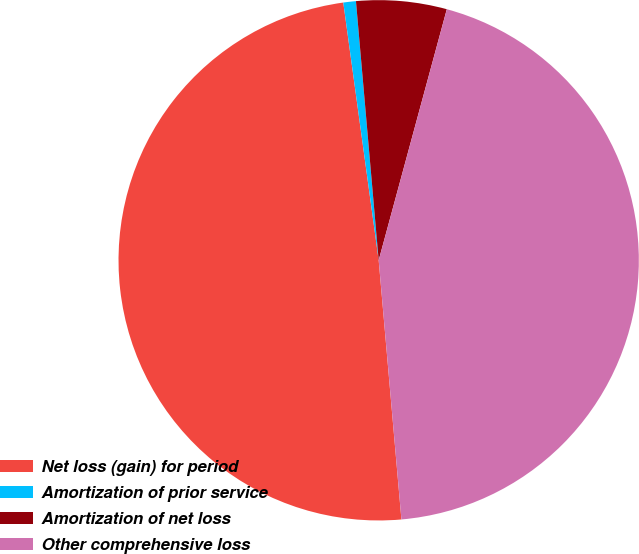Convert chart to OTSL. <chart><loc_0><loc_0><loc_500><loc_500><pie_chart><fcel>Net loss (gain) for period<fcel>Amortization of prior service<fcel>Amortization of net loss<fcel>Other comprehensive loss<nl><fcel>49.22%<fcel>0.78%<fcel>5.61%<fcel>44.39%<nl></chart> 